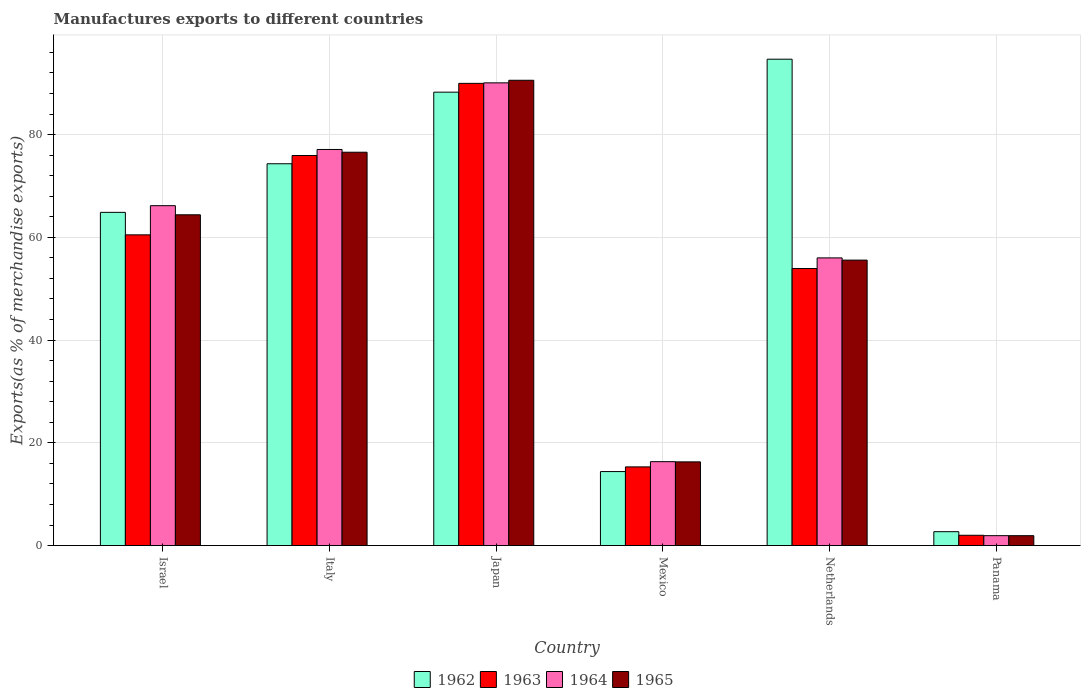How many different coloured bars are there?
Offer a terse response. 4. How many groups of bars are there?
Provide a short and direct response. 6. Are the number of bars per tick equal to the number of legend labels?
Ensure brevity in your answer.  Yes. How many bars are there on the 2nd tick from the left?
Your answer should be compact. 4. What is the label of the 6th group of bars from the left?
Provide a short and direct response. Panama. In how many cases, is the number of bars for a given country not equal to the number of legend labels?
Ensure brevity in your answer.  0. What is the percentage of exports to different countries in 1962 in Panama?
Provide a succinct answer. 2.7. Across all countries, what is the maximum percentage of exports to different countries in 1963?
Provide a short and direct response. 89.97. Across all countries, what is the minimum percentage of exports to different countries in 1965?
Offer a terse response. 1.92. In which country was the percentage of exports to different countries in 1964 minimum?
Give a very brief answer. Panama. What is the total percentage of exports to different countries in 1965 in the graph?
Give a very brief answer. 305.31. What is the difference between the percentage of exports to different countries in 1962 in Italy and that in Japan?
Provide a succinct answer. -13.94. What is the difference between the percentage of exports to different countries in 1965 in Japan and the percentage of exports to different countries in 1963 in Israel?
Give a very brief answer. 30.09. What is the average percentage of exports to different countries in 1965 per country?
Provide a succinct answer. 50.88. What is the difference between the percentage of exports to different countries of/in 1965 and percentage of exports to different countries of/in 1962 in Mexico?
Make the answer very short. 1.89. What is the ratio of the percentage of exports to different countries in 1962 in Japan to that in Mexico?
Provide a short and direct response. 6.13. Is the difference between the percentage of exports to different countries in 1965 in Israel and Netherlands greater than the difference between the percentage of exports to different countries in 1962 in Israel and Netherlands?
Give a very brief answer. Yes. What is the difference between the highest and the second highest percentage of exports to different countries in 1964?
Provide a succinct answer. -23.91. What is the difference between the highest and the lowest percentage of exports to different countries in 1964?
Keep it short and to the point. 88.15. What does the 2nd bar from the left in Italy represents?
Make the answer very short. 1963. What does the 2nd bar from the right in Italy represents?
Keep it short and to the point. 1964. Is it the case that in every country, the sum of the percentage of exports to different countries in 1965 and percentage of exports to different countries in 1963 is greater than the percentage of exports to different countries in 1964?
Your answer should be compact. Yes. Are all the bars in the graph horizontal?
Your answer should be very brief. No. How many countries are there in the graph?
Offer a terse response. 6. What is the difference between two consecutive major ticks on the Y-axis?
Provide a succinct answer. 20. Does the graph contain grids?
Give a very brief answer. Yes. How many legend labels are there?
Keep it short and to the point. 4. How are the legend labels stacked?
Your answer should be compact. Horizontal. What is the title of the graph?
Make the answer very short. Manufactures exports to different countries. Does "1970" appear as one of the legend labels in the graph?
Your answer should be very brief. No. What is the label or title of the X-axis?
Give a very brief answer. Country. What is the label or title of the Y-axis?
Make the answer very short. Exports(as % of merchandise exports). What is the Exports(as % of merchandise exports) of 1962 in Israel?
Offer a terse response. 64.86. What is the Exports(as % of merchandise exports) of 1963 in Israel?
Make the answer very short. 60.48. What is the Exports(as % of merchandise exports) of 1964 in Israel?
Ensure brevity in your answer.  66.16. What is the Exports(as % of merchandise exports) of 1965 in Israel?
Your response must be concise. 64.39. What is the Exports(as % of merchandise exports) of 1962 in Italy?
Provide a short and direct response. 74.32. What is the Exports(as % of merchandise exports) in 1963 in Italy?
Offer a terse response. 75.93. What is the Exports(as % of merchandise exports) of 1964 in Italy?
Keep it short and to the point. 77.1. What is the Exports(as % of merchandise exports) of 1965 in Italy?
Keep it short and to the point. 76.57. What is the Exports(as % of merchandise exports) in 1962 in Japan?
Offer a very short reply. 88.26. What is the Exports(as % of merchandise exports) of 1963 in Japan?
Your answer should be compact. 89.97. What is the Exports(as % of merchandise exports) of 1964 in Japan?
Keep it short and to the point. 90.07. What is the Exports(as % of merchandise exports) in 1965 in Japan?
Your response must be concise. 90.57. What is the Exports(as % of merchandise exports) in 1962 in Mexico?
Ensure brevity in your answer.  14.4. What is the Exports(as % of merchandise exports) of 1963 in Mexico?
Your answer should be very brief. 15.31. What is the Exports(as % of merchandise exports) of 1964 in Mexico?
Keep it short and to the point. 16.33. What is the Exports(as % of merchandise exports) in 1965 in Mexico?
Give a very brief answer. 16.29. What is the Exports(as % of merchandise exports) in 1962 in Netherlands?
Provide a succinct answer. 94.68. What is the Exports(as % of merchandise exports) in 1963 in Netherlands?
Offer a terse response. 53.93. What is the Exports(as % of merchandise exports) in 1964 in Netherlands?
Offer a very short reply. 56. What is the Exports(as % of merchandise exports) in 1965 in Netherlands?
Offer a very short reply. 55.57. What is the Exports(as % of merchandise exports) in 1962 in Panama?
Provide a succinct answer. 2.7. What is the Exports(as % of merchandise exports) of 1963 in Panama?
Give a very brief answer. 2. What is the Exports(as % of merchandise exports) in 1964 in Panama?
Offer a very short reply. 1.93. What is the Exports(as % of merchandise exports) of 1965 in Panama?
Ensure brevity in your answer.  1.92. Across all countries, what is the maximum Exports(as % of merchandise exports) in 1962?
Give a very brief answer. 94.68. Across all countries, what is the maximum Exports(as % of merchandise exports) of 1963?
Ensure brevity in your answer.  89.97. Across all countries, what is the maximum Exports(as % of merchandise exports) of 1964?
Provide a short and direct response. 90.07. Across all countries, what is the maximum Exports(as % of merchandise exports) of 1965?
Keep it short and to the point. 90.57. Across all countries, what is the minimum Exports(as % of merchandise exports) of 1962?
Provide a short and direct response. 2.7. Across all countries, what is the minimum Exports(as % of merchandise exports) of 1963?
Your answer should be compact. 2. Across all countries, what is the minimum Exports(as % of merchandise exports) in 1964?
Give a very brief answer. 1.93. Across all countries, what is the minimum Exports(as % of merchandise exports) in 1965?
Keep it short and to the point. 1.92. What is the total Exports(as % of merchandise exports) in 1962 in the graph?
Your response must be concise. 339.23. What is the total Exports(as % of merchandise exports) in 1963 in the graph?
Offer a very short reply. 297.63. What is the total Exports(as % of merchandise exports) in 1964 in the graph?
Offer a terse response. 307.59. What is the total Exports(as % of merchandise exports) in 1965 in the graph?
Provide a short and direct response. 305.31. What is the difference between the Exports(as % of merchandise exports) in 1962 in Israel and that in Italy?
Your response must be concise. -9.46. What is the difference between the Exports(as % of merchandise exports) in 1963 in Israel and that in Italy?
Keep it short and to the point. -15.45. What is the difference between the Exports(as % of merchandise exports) in 1964 in Israel and that in Italy?
Keep it short and to the point. -10.94. What is the difference between the Exports(as % of merchandise exports) in 1965 in Israel and that in Italy?
Your answer should be very brief. -12.18. What is the difference between the Exports(as % of merchandise exports) in 1962 in Israel and that in Japan?
Keep it short and to the point. -23.4. What is the difference between the Exports(as % of merchandise exports) in 1963 in Israel and that in Japan?
Your answer should be compact. -29.49. What is the difference between the Exports(as % of merchandise exports) in 1964 in Israel and that in Japan?
Ensure brevity in your answer.  -23.91. What is the difference between the Exports(as % of merchandise exports) of 1965 in Israel and that in Japan?
Offer a terse response. -26.18. What is the difference between the Exports(as % of merchandise exports) in 1962 in Israel and that in Mexico?
Your answer should be very brief. 50.46. What is the difference between the Exports(as % of merchandise exports) in 1963 in Israel and that in Mexico?
Give a very brief answer. 45.17. What is the difference between the Exports(as % of merchandise exports) of 1964 in Israel and that in Mexico?
Make the answer very short. 49.83. What is the difference between the Exports(as % of merchandise exports) in 1965 in Israel and that in Mexico?
Offer a very short reply. 48.1. What is the difference between the Exports(as % of merchandise exports) in 1962 in Israel and that in Netherlands?
Your answer should be very brief. -29.81. What is the difference between the Exports(as % of merchandise exports) of 1963 in Israel and that in Netherlands?
Give a very brief answer. 6.55. What is the difference between the Exports(as % of merchandise exports) of 1964 in Israel and that in Netherlands?
Your answer should be compact. 10.16. What is the difference between the Exports(as % of merchandise exports) in 1965 in Israel and that in Netherlands?
Keep it short and to the point. 8.82. What is the difference between the Exports(as % of merchandise exports) of 1962 in Israel and that in Panama?
Offer a very short reply. 62.16. What is the difference between the Exports(as % of merchandise exports) in 1963 in Israel and that in Panama?
Your answer should be very brief. 58.48. What is the difference between the Exports(as % of merchandise exports) of 1964 in Israel and that in Panama?
Make the answer very short. 64.23. What is the difference between the Exports(as % of merchandise exports) in 1965 in Israel and that in Panama?
Offer a very short reply. 62.47. What is the difference between the Exports(as % of merchandise exports) of 1962 in Italy and that in Japan?
Ensure brevity in your answer.  -13.94. What is the difference between the Exports(as % of merchandise exports) in 1963 in Italy and that in Japan?
Keep it short and to the point. -14.04. What is the difference between the Exports(as % of merchandise exports) in 1964 in Italy and that in Japan?
Provide a short and direct response. -12.97. What is the difference between the Exports(as % of merchandise exports) in 1965 in Italy and that in Japan?
Make the answer very short. -14.01. What is the difference between the Exports(as % of merchandise exports) in 1962 in Italy and that in Mexico?
Make the answer very short. 59.92. What is the difference between the Exports(as % of merchandise exports) in 1963 in Italy and that in Mexico?
Provide a short and direct response. 60.61. What is the difference between the Exports(as % of merchandise exports) of 1964 in Italy and that in Mexico?
Make the answer very short. 60.77. What is the difference between the Exports(as % of merchandise exports) in 1965 in Italy and that in Mexico?
Provide a succinct answer. 60.28. What is the difference between the Exports(as % of merchandise exports) of 1962 in Italy and that in Netherlands?
Give a very brief answer. -20.36. What is the difference between the Exports(as % of merchandise exports) in 1963 in Italy and that in Netherlands?
Give a very brief answer. 22. What is the difference between the Exports(as % of merchandise exports) in 1964 in Italy and that in Netherlands?
Provide a short and direct response. 21.11. What is the difference between the Exports(as % of merchandise exports) of 1965 in Italy and that in Netherlands?
Ensure brevity in your answer.  21. What is the difference between the Exports(as % of merchandise exports) of 1962 in Italy and that in Panama?
Your answer should be very brief. 71.62. What is the difference between the Exports(as % of merchandise exports) in 1963 in Italy and that in Panama?
Give a very brief answer. 73.92. What is the difference between the Exports(as % of merchandise exports) in 1964 in Italy and that in Panama?
Give a very brief answer. 75.18. What is the difference between the Exports(as % of merchandise exports) of 1965 in Italy and that in Panama?
Your response must be concise. 74.64. What is the difference between the Exports(as % of merchandise exports) of 1962 in Japan and that in Mexico?
Offer a terse response. 73.86. What is the difference between the Exports(as % of merchandise exports) of 1963 in Japan and that in Mexico?
Provide a succinct answer. 74.66. What is the difference between the Exports(as % of merchandise exports) in 1964 in Japan and that in Mexico?
Offer a terse response. 73.74. What is the difference between the Exports(as % of merchandise exports) of 1965 in Japan and that in Mexico?
Your answer should be compact. 74.28. What is the difference between the Exports(as % of merchandise exports) in 1962 in Japan and that in Netherlands?
Offer a very short reply. -6.42. What is the difference between the Exports(as % of merchandise exports) in 1963 in Japan and that in Netherlands?
Offer a very short reply. 36.04. What is the difference between the Exports(as % of merchandise exports) in 1964 in Japan and that in Netherlands?
Keep it short and to the point. 34.07. What is the difference between the Exports(as % of merchandise exports) of 1965 in Japan and that in Netherlands?
Offer a terse response. 35.01. What is the difference between the Exports(as % of merchandise exports) in 1962 in Japan and that in Panama?
Your response must be concise. 85.56. What is the difference between the Exports(as % of merchandise exports) in 1963 in Japan and that in Panama?
Make the answer very short. 87.97. What is the difference between the Exports(as % of merchandise exports) in 1964 in Japan and that in Panama?
Your response must be concise. 88.15. What is the difference between the Exports(as % of merchandise exports) of 1965 in Japan and that in Panama?
Provide a short and direct response. 88.65. What is the difference between the Exports(as % of merchandise exports) of 1962 in Mexico and that in Netherlands?
Make the answer very short. -80.27. What is the difference between the Exports(as % of merchandise exports) in 1963 in Mexico and that in Netherlands?
Provide a short and direct response. -38.62. What is the difference between the Exports(as % of merchandise exports) of 1964 in Mexico and that in Netherlands?
Your answer should be compact. -39.67. What is the difference between the Exports(as % of merchandise exports) in 1965 in Mexico and that in Netherlands?
Ensure brevity in your answer.  -39.28. What is the difference between the Exports(as % of merchandise exports) of 1962 in Mexico and that in Panama?
Ensure brevity in your answer.  11.7. What is the difference between the Exports(as % of merchandise exports) in 1963 in Mexico and that in Panama?
Provide a succinct answer. 13.31. What is the difference between the Exports(as % of merchandise exports) in 1964 in Mexico and that in Panama?
Provide a succinct answer. 14.4. What is the difference between the Exports(as % of merchandise exports) of 1965 in Mexico and that in Panama?
Your response must be concise. 14.37. What is the difference between the Exports(as % of merchandise exports) in 1962 in Netherlands and that in Panama?
Your response must be concise. 91.97. What is the difference between the Exports(as % of merchandise exports) of 1963 in Netherlands and that in Panama?
Provide a succinct answer. 51.93. What is the difference between the Exports(as % of merchandise exports) of 1964 in Netherlands and that in Panama?
Your response must be concise. 54.07. What is the difference between the Exports(as % of merchandise exports) of 1965 in Netherlands and that in Panama?
Provide a succinct answer. 53.64. What is the difference between the Exports(as % of merchandise exports) of 1962 in Israel and the Exports(as % of merchandise exports) of 1963 in Italy?
Give a very brief answer. -11.07. What is the difference between the Exports(as % of merchandise exports) of 1962 in Israel and the Exports(as % of merchandise exports) of 1964 in Italy?
Give a very brief answer. -12.24. What is the difference between the Exports(as % of merchandise exports) in 1962 in Israel and the Exports(as % of merchandise exports) in 1965 in Italy?
Provide a succinct answer. -11.7. What is the difference between the Exports(as % of merchandise exports) of 1963 in Israel and the Exports(as % of merchandise exports) of 1964 in Italy?
Your answer should be very brief. -16.62. What is the difference between the Exports(as % of merchandise exports) in 1963 in Israel and the Exports(as % of merchandise exports) in 1965 in Italy?
Offer a very short reply. -16.08. What is the difference between the Exports(as % of merchandise exports) of 1964 in Israel and the Exports(as % of merchandise exports) of 1965 in Italy?
Offer a very short reply. -10.41. What is the difference between the Exports(as % of merchandise exports) in 1962 in Israel and the Exports(as % of merchandise exports) in 1963 in Japan?
Your answer should be very brief. -25.11. What is the difference between the Exports(as % of merchandise exports) of 1962 in Israel and the Exports(as % of merchandise exports) of 1964 in Japan?
Give a very brief answer. -25.21. What is the difference between the Exports(as % of merchandise exports) of 1962 in Israel and the Exports(as % of merchandise exports) of 1965 in Japan?
Ensure brevity in your answer.  -25.71. What is the difference between the Exports(as % of merchandise exports) in 1963 in Israel and the Exports(as % of merchandise exports) in 1964 in Japan?
Provide a succinct answer. -29.59. What is the difference between the Exports(as % of merchandise exports) in 1963 in Israel and the Exports(as % of merchandise exports) in 1965 in Japan?
Make the answer very short. -30.09. What is the difference between the Exports(as % of merchandise exports) of 1964 in Israel and the Exports(as % of merchandise exports) of 1965 in Japan?
Ensure brevity in your answer.  -24.41. What is the difference between the Exports(as % of merchandise exports) of 1962 in Israel and the Exports(as % of merchandise exports) of 1963 in Mexico?
Ensure brevity in your answer.  49.55. What is the difference between the Exports(as % of merchandise exports) in 1962 in Israel and the Exports(as % of merchandise exports) in 1964 in Mexico?
Your response must be concise. 48.53. What is the difference between the Exports(as % of merchandise exports) of 1962 in Israel and the Exports(as % of merchandise exports) of 1965 in Mexico?
Your answer should be compact. 48.57. What is the difference between the Exports(as % of merchandise exports) of 1963 in Israel and the Exports(as % of merchandise exports) of 1964 in Mexico?
Provide a succinct answer. 44.15. What is the difference between the Exports(as % of merchandise exports) in 1963 in Israel and the Exports(as % of merchandise exports) in 1965 in Mexico?
Provide a short and direct response. 44.19. What is the difference between the Exports(as % of merchandise exports) in 1964 in Israel and the Exports(as % of merchandise exports) in 1965 in Mexico?
Provide a short and direct response. 49.87. What is the difference between the Exports(as % of merchandise exports) in 1962 in Israel and the Exports(as % of merchandise exports) in 1963 in Netherlands?
Your answer should be compact. 10.93. What is the difference between the Exports(as % of merchandise exports) in 1962 in Israel and the Exports(as % of merchandise exports) in 1964 in Netherlands?
Ensure brevity in your answer.  8.87. What is the difference between the Exports(as % of merchandise exports) of 1962 in Israel and the Exports(as % of merchandise exports) of 1965 in Netherlands?
Ensure brevity in your answer.  9.3. What is the difference between the Exports(as % of merchandise exports) of 1963 in Israel and the Exports(as % of merchandise exports) of 1964 in Netherlands?
Give a very brief answer. 4.49. What is the difference between the Exports(as % of merchandise exports) of 1963 in Israel and the Exports(as % of merchandise exports) of 1965 in Netherlands?
Keep it short and to the point. 4.92. What is the difference between the Exports(as % of merchandise exports) of 1964 in Israel and the Exports(as % of merchandise exports) of 1965 in Netherlands?
Make the answer very short. 10.59. What is the difference between the Exports(as % of merchandise exports) in 1962 in Israel and the Exports(as % of merchandise exports) in 1963 in Panama?
Your response must be concise. 62.86. What is the difference between the Exports(as % of merchandise exports) in 1962 in Israel and the Exports(as % of merchandise exports) in 1964 in Panama?
Keep it short and to the point. 62.94. What is the difference between the Exports(as % of merchandise exports) in 1962 in Israel and the Exports(as % of merchandise exports) in 1965 in Panama?
Your response must be concise. 62.94. What is the difference between the Exports(as % of merchandise exports) of 1963 in Israel and the Exports(as % of merchandise exports) of 1964 in Panama?
Ensure brevity in your answer.  58.56. What is the difference between the Exports(as % of merchandise exports) in 1963 in Israel and the Exports(as % of merchandise exports) in 1965 in Panama?
Provide a succinct answer. 58.56. What is the difference between the Exports(as % of merchandise exports) in 1964 in Israel and the Exports(as % of merchandise exports) in 1965 in Panama?
Offer a terse response. 64.24. What is the difference between the Exports(as % of merchandise exports) in 1962 in Italy and the Exports(as % of merchandise exports) in 1963 in Japan?
Make the answer very short. -15.65. What is the difference between the Exports(as % of merchandise exports) of 1962 in Italy and the Exports(as % of merchandise exports) of 1964 in Japan?
Offer a terse response. -15.75. What is the difference between the Exports(as % of merchandise exports) of 1962 in Italy and the Exports(as % of merchandise exports) of 1965 in Japan?
Your response must be concise. -16.25. What is the difference between the Exports(as % of merchandise exports) in 1963 in Italy and the Exports(as % of merchandise exports) in 1964 in Japan?
Offer a terse response. -14.14. What is the difference between the Exports(as % of merchandise exports) of 1963 in Italy and the Exports(as % of merchandise exports) of 1965 in Japan?
Give a very brief answer. -14.64. What is the difference between the Exports(as % of merchandise exports) in 1964 in Italy and the Exports(as % of merchandise exports) in 1965 in Japan?
Provide a short and direct response. -13.47. What is the difference between the Exports(as % of merchandise exports) of 1962 in Italy and the Exports(as % of merchandise exports) of 1963 in Mexico?
Provide a succinct answer. 59.01. What is the difference between the Exports(as % of merchandise exports) in 1962 in Italy and the Exports(as % of merchandise exports) in 1964 in Mexico?
Give a very brief answer. 57.99. What is the difference between the Exports(as % of merchandise exports) of 1962 in Italy and the Exports(as % of merchandise exports) of 1965 in Mexico?
Your answer should be compact. 58.03. What is the difference between the Exports(as % of merchandise exports) of 1963 in Italy and the Exports(as % of merchandise exports) of 1964 in Mexico?
Provide a succinct answer. 59.6. What is the difference between the Exports(as % of merchandise exports) of 1963 in Italy and the Exports(as % of merchandise exports) of 1965 in Mexico?
Ensure brevity in your answer.  59.64. What is the difference between the Exports(as % of merchandise exports) of 1964 in Italy and the Exports(as % of merchandise exports) of 1965 in Mexico?
Provide a short and direct response. 60.81. What is the difference between the Exports(as % of merchandise exports) of 1962 in Italy and the Exports(as % of merchandise exports) of 1963 in Netherlands?
Offer a terse response. 20.39. What is the difference between the Exports(as % of merchandise exports) of 1962 in Italy and the Exports(as % of merchandise exports) of 1964 in Netherlands?
Make the answer very short. 18.32. What is the difference between the Exports(as % of merchandise exports) in 1962 in Italy and the Exports(as % of merchandise exports) in 1965 in Netherlands?
Your response must be concise. 18.76. What is the difference between the Exports(as % of merchandise exports) in 1963 in Italy and the Exports(as % of merchandise exports) in 1964 in Netherlands?
Provide a short and direct response. 19.93. What is the difference between the Exports(as % of merchandise exports) of 1963 in Italy and the Exports(as % of merchandise exports) of 1965 in Netherlands?
Keep it short and to the point. 20.36. What is the difference between the Exports(as % of merchandise exports) in 1964 in Italy and the Exports(as % of merchandise exports) in 1965 in Netherlands?
Offer a very short reply. 21.54. What is the difference between the Exports(as % of merchandise exports) in 1962 in Italy and the Exports(as % of merchandise exports) in 1963 in Panama?
Offer a very short reply. 72.32. What is the difference between the Exports(as % of merchandise exports) of 1962 in Italy and the Exports(as % of merchandise exports) of 1964 in Panama?
Keep it short and to the point. 72.39. What is the difference between the Exports(as % of merchandise exports) of 1962 in Italy and the Exports(as % of merchandise exports) of 1965 in Panama?
Offer a very short reply. 72.4. What is the difference between the Exports(as % of merchandise exports) of 1963 in Italy and the Exports(as % of merchandise exports) of 1964 in Panama?
Offer a terse response. 74. What is the difference between the Exports(as % of merchandise exports) in 1963 in Italy and the Exports(as % of merchandise exports) in 1965 in Panama?
Provide a succinct answer. 74.01. What is the difference between the Exports(as % of merchandise exports) of 1964 in Italy and the Exports(as % of merchandise exports) of 1965 in Panama?
Your answer should be compact. 75.18. What is the difference between the Exports(as % of merchandise exports) of 1962 in Japan and the Exports(as % of merchandise exports) of 1963 in Mexico?
Keep it short and to the point. 72.95. What is the difference between the Exports(as % of merchandise exports) in 1962 in Japan and the Exports(as % of merchandise exports) in 1964 in Mexico?
Give a very brief answer. 71.93. What is the difference between the Exports(as % of merchandise exports) in 1962 in Japan and the Exports(as % of merchandise exports) in 1965 in Mexico?
Keep it short and to the point. 71.97. What is the difference between the Exports(as % of merchandise exports) of 1963 in Japan and the Exports(as % of merchandise exports) of 1964 in Mexico?
Your answer should be very brief. 73.64. What is the difference between the Exports(as % of merchandise exports) in 1963 in Japan and the Exports(as % of merchandise exports) in 1965 in Mexico?
Your answer should be very brief. 73.68. What is the difference between the Exports(as % of merchandise exports) in 1964 in Japan and the Exports(as % of merchandise exports) in 1965 in Mexico?
Offer a terse response. 73.78. What is the difference between the Exports(as % of merchandise exports) in 1962 in Japan and the Exports(as % of merchandise exports) in 1963 in Netherlands?
Offer a very short reply. 34.33. What is the difference between the Exports(as % of merchandise exports) in 1962 in Japan and the Exports(as % of merchandise exports) in 1964 in Netherlands?
Keep it short and to the point. 32.26. What is the difference between the Exports(as % of merchandise exports) of 1962 in Japan and the Exports(as % of merchandise exports) of 1965 in Netherlands?
Your answer should be very brief. 32.69. What is the difference between the Exports(as % of merchandise exports) in 1963 in Japan and the Exports(as % of merchandise exports) in 1964 in Netherlands?
Your response must be concise. 33.97. What is the difference between the Exports(as % of merchandise exports) of 1963 in Japan and the Exports(as % of merchandise exports) of 1965 in Netherlands?
Offer a very short reply. 34.41. What is the difference between the Exports(as % of merchandise exports) of 1964 in Japan and the Exports(as % of merchandise exports) of 1965 in Netherlands?
Ensure brevity in your answer.  34.51. What is the difference between the Exports(as % of merchandise exports) of 1962 in Japan and the Exports(as % of merchandise exports) of 1963 in Panama?
Provide a succinct answer. 86.26. What is the difference between the Exports(as % of merchandise exports) in 1962 in Japan and the Exports(as % of merchandise exports) in 1964 in Panama?
Offer a very short reply. 86.33. What is the difference between the Exports(as % of merchandise exports) in 1962 in Japan and the Exports(as % of merchandise exports) in 1965 in Panama?
Ensure brevity in your answer.  86.34. What is the difference between the Exports(as % of merchandise exports) in 1963 in Japan and the Exports(as % of merchandise exports) in 1964 in Panama?
Provide a succinct answer. 88.05. What is the difference between the Exports(as % of merchandise exports) in 1963 in Japan and the Exports(as % of merchandise exports) in 1965 in Panama?
Your response must be concise. 88.05. What is the difference between the Exports(as % of merchandise exports) of 1964 in Japan and the Exports(as % of merchandise exports) of 1965 in Panama?
Keep it short and to the point. 88.15. What is the difference between the Exports(as % of merchandise exports) in 1962 in Mexico and the Exports(as % of merchandise exports) in 1963 in Netherlands?
Offer a terse response. -39.53. What is the difference between the Exports(as % of merchandise exports) of 1962 in Mexico and the Exports(as % of merchandise exports) of 1964 in Netherlands?
Provide a succinct answer. -41.59. What is the difference between the Exports(as % of merchandise exports) of 1962 in Mexico and the Exports(as % of merchandise exports) of 1965 in Netherlands?
Your answer should be compact. -41.16. What is the difference between the Exports(as % of merchandise exports) in 1963 in Mexico and the Exports(as % of merchandise exports) in 1964 in Netherlands?
Your response must be concise. -40.68. What is the difference between the Exports(as % of merchandise exports) of 1963 in Mexico and the Exports(as % of merchandise exports) of 1965 in Netherlands?
Offer a terse response. -40.25. What is the difference between the Exports(as % of merchandise exports) of 1964 in Mexico and the Exports(as % of merchandise exports) of 1965 in Netherlands?
Your response must be concise. -39.24. What is the difference between the Exports(as % of merchandise exports) of 1962 in Mexico and the Exports(as % of merchandise exports) of 1963 in Panama?
Ensure brevity in your answer.  12.4. What is the difference between the Exports(as % of merchandise exports) in 1962 in Mexico and the Exports(as % of merchandise exports) in 1964 in Panama?
Your response must be concise. 12.48. What is the difference between the Exports(as % of merchandise exports) of 1962 in Mexico and the Exports(as % of merchandise exports) of 1965 in Panama?
Make the answer very short. 12.48. What is the difference between the Exports(as % of merchandise exports) of 1963 in Mexico and the Exports(as % of merchandise exports) of 1964 in Panama?
Your answer should be very brief. 13.39. What is the difference between the Exports(as % of merchandise exports) of 1963 in Mexico and the Exports(as % of merchandise exports) of 1965 in Panama?
Make the answer very short. 13.39. What is the difference between the Exports(as % of merchandise exports) of 1964 in Mexico and the Exports(as % of merchandise exports) of 1965 in Panama?
Your response must be concise. 14.41. What is the difference between the Exports(as % of merchandise exports) of 1962 in Netherlands and the Exports(as % of merchandise exports) of 1963 in Panama?
Provide a succinct answer. 92.67. What is the difference between the Exports(as % of merchandise exports) of 1962 in Netherlands and the Exports(as % of merchandise exports) of 1964 in Panama?
Provide a short and direct response. 92.75. What is the difference between the Exports(as % of merchandise exports) in 1962 in Netherlands and the Exports(as % of merchandise exports) in 1965 in Panama?
Offer a terse response. 92.75. What is the difference between the Exports(as % of merchandise exports) of 1963 in Netherlands and the Exports(as % of merchandise exports) of 1964 in Panama?
Make the answer very short. 52. What is the difference between the Exports(as % of merchandise exports) of 1963 in Netherlands and the Exports(as % of merchandise exports) of 1965 in Panama?
Your answer should be very brief. 52.01. What is the difference between the Exports(as % of merchandise exports) of 1964 in Netherlands and the Exports(as % of merchandise exports) of 1965 in Panama?
Your answer should be very brief. 54.07. What is the average Exports(as % of merchandise exports) of 1962 per country?
Provide a short and direct response. 56.54. What is the average Exports(as % of merchandise exports) of 1963 per country?
Your answer should be compact. 49.61. What is the average Exports(as % of merchandise exports) of 1964 per country?
Your answer should be compact. 51.27. What is the average Exports(as % of merchandise exports) of 1965 per country?
Provide a short and direct response. 50.88. What is the difference between the Exports(as % of merchandise exports) of 1962 and Exports(as % of merchandise exports) of 1963 in Israel?
Provide a short and direct response. 4.38. What is the difference between the Exports(as % of merchandise exports) of 1962 and Exports(as % of merchandise exports) of 1964 in Israel?
Your response must be concise. -1.3. What is the difference between the Exports(as % of merchandise exports) of 1962 and Exports(as % of merchandise exports) of 1965 in Israel?
Provide a succinct answer. 0.47. What is the difference between the Exports(as % of merchandise exports) in 1963 and Exports(as % of merchandise exports) in 1964 in Israel?
Your answer should be compact. -5.68. What is the difference between the Exports(as % of merchandise exports) of 1963 and Exports(as % of merchandise exports) of 1965 in Israel?
Your answer should be very brief. -3.91. What is the difference between the Exports(as % of merchandise exports) in 1964 and Exports(as % of merchandise exports) in 1965 in Israel?
Provide a short and direct response. 1.77. What is the difference between the Exports(as % of merchandise exports) in 1962 and Exports(as % of merchandise exports) in 1963 in Italy?
Your answer should be compact. -1.61. What is the difference between the Exports(as % of merchandise exports) in 1962 and Exports(as % of merchandise exports) in 1964 in Italy?
Your answer should be very brief. -2.78. What is the difference between the Exports(as % of merchandise exports) in 1962 and Exports(as % of merchandise exports) in 1965 in Italy?
Provide a short and direct response. -2.25. What is the difference between the Exports(as % of merchandise exports) in 1963 and Exports(as % of merchandise exports) in 1964 in Italy?
Offer a very short reply. -1.17. What is the difference between the Exports(as % of merchandise exports) in 1963 and Exports(as % of merchandise exports) in 1965 in Italy?
Your answer should be compact. -0.64. What is the difference between the Exports(as % of merchandise exports) in 1964 and Exports(as % of merchandise exports) in 1965 in Italy?
Your answer should be compact. 0.54. What is the difference between the Exports(as % of merchandise exports) of 1962 and Exports(as % of merchandise exports) of 1963 in Japan?
Your answer should be very brief. -1.71. What is the difference between the Exports(as % of merchandise exports) of 1962 and Exports(as % of merchandise exports) of 1964 in Japan?
Ensure brevity in your answer.  -1.81. What is the difference between the Exports(as % of merchandise exports) of 1962 and Exports(as % of merchandise exports) of 1965 in Japan?
Your answer should be very brief. -2.31. What is the difference between the Exports(as % of merchandise exports) of 1963 and Exports(as % of merchandise exports) of 1964 in Japan?
Your answer should be very brief. -0.1. What is the difference between the Exports(as % of merchandise exports) of 1963 and Exports(as % of merchandise exports) of 1965 in Japan?
Provide a short and direct response. -0.6. What is the difference between the Exports(as % of merchandise exports) in 1964 and Exports(as % of merchandise exports) in 1965 in Japan?
Your answer should be very brief. -0.5. What is the difference between the Exports(as % of merchandise exports) of 1962 and Exports(as % of merchandise exports) of 1963 in Mexico?
Give a very brief answer. -0.91. What is the difference between the Exports(as % of merchandise exports) of 1962 and Exports(as % of merchandise exports) of 1964 in Mexico?
Provide a short and direct response. -1.93. What is the difference between the Exports(as % of merchandise exports) in 1962 and Exports(as % of merchandise exports) in 1965 in Mexico?
Give a very brief answer. -1.89. What is the difference between the Exports(as % of merchandise exports) of 1963 and Exports(as % of merchandise exports) of 1964 in Mexico?
Your answer should be very brief. -1.02. What is the difference between the Exports(as % of merchandise exports) of 1963 and Exports(as % of merchandise exports) of 1965 in Mexico?
Provide a short and direct response. -0.98. What is the difference between the Exports(as % of merchandise exports) of 1964 and Exports(as % of merchandise exports) of 1965 in Mexico?
Your answer should be very brief. 0.04. What is the difference between the Exports(as % of merchandise exports) in 1962 and Exports(as % of merchandise exports) in 1963 in Netherlands?
Provide a succinct answer. 40.75. What is the difference between the Exports(as % of merchandise exports) in 1962 and Exports(as % of merchandise exports) in 1964 in Netherlands?
Your response must be concise. 38.68. What is the difference between the Exports(as % of merchandise exports) in 1962 and Exports(as % of merchandise exports) in 1965 in Netherlands?
Keep it short and to the point. 39.11. What is the difference between the Exports(as % of merchandise exports) in 1963 and Exports(as % of merchandise exports) in 1964 in Netherlands?
Give a very brief answer. -2.07. What is the difference between the Exports(as % of merchandise exports) of 1963 and Exports(as % of merchandise exports) of 1965 in Netherlands?
Make the answer very short. -1.64. What is the difference between the Exports(as % of merchandise exports) in 1964 and Exports(as % of merchandise exports) in 1965 in Netherlands?
Ensure brevity in your answer.  0.43. What is the difference between the Exports(as % of merchandise exports) of 1962 and Exports(as % of merchandise exports) of 1963 in Panama?
Offer a very short reply. 0.7. What is the difference between the Exports(as % of merchandise exports) of 1962 and Exports(as % of merchandise exports) of 1964 in Panama?
Provide a short and direct response. 0.78. What is the difference between the Exports(as % of merchandise exports) of 1962 and Exports(as % of merchandise exports) of 1965 in Panama?
Provide a succinct answer. 0.78. What is the difference between the Exports(as % of merchandise exports) of 1963 and Exports(as % of merchandise exports) of 1964 in Panama?
Your answer should be compact. 0.08. What is the difference between the Exports(as % of merchandise exports) in 1963 and Exports(as % of merchandise exports) in 1965 in Panama?
Make the answer very short. 0.08. What is the difference between the Exports(as % of merchandise exports) in 1964 and Exports(as % of merchandise exports) in 1965 in Panama?
Your response must be concise. 0. What is the ratio of the Exports(as % of merchandise exports) of 1962 in Israel to that in Italy?
Keep it short and to the point. 0.87. What is the ratio of the Exports(as % of merchandise exports) in 1963 in Israel to that in Italy?
Keep it short and to the point. 0.8. What is the ratio of the Exports(as % of merchandise exports) in 1964 in Israel to that in Italy?
Give a very brief answer. 0.86. What is the ratio of the Exports(as % of merchandise exports) of 1965 in Israel to that in Italy?
Ensure brevity in your answer.  0.84. What is the ratio of the Exports(as % of merchandise exports) in 1962 in Israel to that in Japan?
Provide a succinct answer. 0.73. What is the ratio of the Exports(as % of merchandise exports) of 1963 in Israel to that in Japan?
Offer a terse response. 0.67. What is the ratio of the Exports(as % of merchandise exports) in 1964 in Israel to that in Japan?
Offer a terse response. 0.73. What is the ratio of the Exports(as % of merchandise exports) in 1965 in Israel to that in Japan?
Your answer should be compact. 0.71. What is the ratio of the Exports(as % of merchandise exports) of 1962 in Israel to that in Mexico?
Your answer should be very brief. 4.5. What is the ratio of the Exports(as % of merchandise exports) in 1963 in Israel to that in Mexico?
Ensure brevity in your answer.  3.95. What is the ratio of the Exports(as % of merchandise exports) of 1964 in Israel to that in Mexico?
Ensure brevity in your answer.  4.05. What is the ratio of the Exports(as % of merchandise exports) in 1965 in Israel to that in Mexico?
Offer a very short reply. 3.95. What is the ratio of the Exports(as % of merchandise exports) of 1962 in Israel to that in Netherlands?
Give a very brief answer. 0.69. What is the ratio of the Exports(as % of merchandise exports) of 1963 in Israel to that in Netherlands?
Provide a short and direct response. 1.12. What is the ratio of the Exports(as % of merchandise exports) in 1964 in Israel to that in Netherlands?
Offer a very short reply. 1.18. What is the ratio of the Exports(as % of merchandise exports) of 1965 in Israel to that in Netherlands?
Keep it short and to the point. 1.16. What is the ratio of the Exports(as % of merchandise exports) in 1962 in Israel to that in Panama?
Provide a short and direct response. 23.99. What is the ratio of the Exports(as % of merchandise exports) in 1963 in Israel to that in Panama?
Your answer should be very brief. 30.18. What is the ratio of the Exports(as % of merchandise exports) in 1964 in Israel to that in Panama?
Your answer should be very brief. 34.34. What is the ratio of the Exports(as % of merchandise exports) in 1965 in Israel to that in Panama?
Your response must be concise. 33.49. What is the ratio of the Exports(as % of merchandise exports) of 1962 in Italy to that in Japan?
Offer a very short reply. 0.84. What is the ratio of the Exports(as % of merchandise exports) of 1963 in Italy to that in Japan?
Ensure brevity in your answer.  0.84. What is the ratio of the Exports(as % of merchandise exports) in 1964 in Italy to that in Japan?
Ensure brevity in your answer.  0.86. What is the ratio of the Exports(as % of merchandise exports) in 1965 in Italy to that in Japan?
Your answer should be compact. 0.85. What is the ratio of the Exports(as % of merchandise exports) in 1962 in Italy to that in Mexico?
Ensure brevity in your answer.  5.16. What is the ratio of the Exports(as % of merchandise exports) in 1963 in Italy to that in Mexico?
Make the answer very short. 4.96. What is the ratio of the Exports(as % of merchandise exports) of 1964 in Italy to that in Mexico?
Offer a very short reply. 4.72. What is the ratio of the Exports(as % of merchandise exports) in 1965 in Italy to that in Mexico?
Keep it short and to the point. 4.7. What is the ratio of the Exports(as % of merchandise exports) of 1962 in Italy to that in Netherlands?
Your answer should be very brief. 0.79. What is the ratio of the Exports(as % of merchandise exports) in 1963 in Italy to that in Netherlands?
Provide a succinct answer. 1.41. What is the ratio of the Exports(as % of merchandise exports) of 1964 in Italy to that in Netherlands?
Your response must be concise. 1.38. What is the ratio of the Exports(as % of merchandise exports) in 1965 in Italy to that in Netherlands?
Offer a terse response. 1.38. What is the ratio of the Exports(as % of merchandise exports) of 1962 in Italy to that in Panama?
Ensure brevity in your answer.  27.49. What is the ratio of the Exports(as % of merchandise exports) of 1963 in Italy to that in Panama?
Your response must be concise. 37.88. What is the ratio of the Exports(as % of merchandise exports) of 1964 in Italy to that in Panama?
Provide a short and direct response. 40.02. What is the ratio of the Exports(as % of merchandise exports) in 1965 in Italy to that in Panama?
Offer a terse response. 39.82. What is the ratio of the Exports(as % of merchandise exports) of 1962 in Japan to that in Mexico?
Ensure brevity in your answer.  6.13. What is the ratio of the Exports(as % of merchandise exports) of 1963 in Japan to that in Mexico?
Your response must be concise. 5.88. What is the ratio of the Exports(as % of merchandise exports) of 1964 in Japan to that in Mexico?
Ensure brevity in your answer.  5.52. What is the ratio of the Exports(as % of merchandise exports) of 1965 in Japan to that in Mexico?
Give a very brief answer. 5.56. What is the ratio of the Exports(as % of merchandise exports) in 1962 in Japan to that in Netherlands?
Your answer should be compact. 0.93. What is the ratio of the Exports(as % of merchandise exports) of 1963 in Japan to that in Netherlands?
Ensure brevity in your answer.  1.67. What is the ratio of the Exports(as % of merchandise exports) of 1964 in Japan to that in Netherlands?
Offer a very short reply. 1.61. What is the ratio of the Exports(as % of merchandise exports) in 1965 in Japan to that in Netherlands?
Your response must be concise. 1.63. What is the ratio of the Exports(as % of merchandise exports) in 1962 in Japan to that in Panama?
Provide a succinct answer. 32.64. What is the ratio of the Exports(as % of merchandise exports) in 1963 in Japan to that in Panama?
Ensure brevity in your answer.  44.89. What is the ratio of the Exports(as % of merchandise exports) in 1964 in Japan to that in Panama?
Your response must be concise. 46.75. What is the ratio of the Exports(as % of merchandise exports) of 1965 in Japan to that in Panama?
Give a very brief answer. 47.1. What is the ratio of the Exports(as % of merchandise exports) in 1962 in Mexico to that in Netherlands?
Offer a very short reply. 0.15. What is the ratio of the Exports(as % of merchandise exports) of 1963 in Mexico to that in Netherlands?
Offer a terse response. 0.28. What is the ratio of the Exports(as % of merchandise exports) in 1964 in Mexico to that in Netherlands?
Offer a terse response. 0.29. What is the ratio of the Exports(as % of merchandise exports) of 1965 in Mexico to that in Netherlands?
Make the answer very short. 0.29. What is the ratio of the Exports(as % of merchandise exports) of 1962 in Mexico to that in Panama?
Provide a short and direct response. 5.33. What is the ratio of the Exports(as % of merchandise exports) of 1963 in Mexico to that in Panama?
Provide a succinct answer. 7.64. What is the ratio of the Exports(as % of merchandise exports) in 1964 in Mexico to that in Panama?
Your answer should be very brief. 8.48. What is the ratio of the Exports(as % of merchandise exports) in 1965 in Mexico to that in Panama?
Your answer should be very brief. 8.47. What is the ratio of the Exports(as % of merchandise exports) in 1962 in Netherlands to that in Panama?
Your response must be concise. 35.02. What is the ratio of the Exports(as % of merchandise exports) in 1963 in Netherlands to that in Panama?
Offer a very short reply. 26.91. What is the ratio of the Exports(as % of merchandise exports) in 1964 in Netherlands to that in Panama?
Keep it short and to the point. 29.06. What is the ratio of the Exports(as % of merchandise exports) in 1965 in Netherlands to that in Panama?
Give a very brief answer. 28.9. What is the difference between the highest and the second highest Exports(as % of merchandise exports) of 1962?
Provide a succinct answer. 6.42. What is the difference between the highest and the second highest Exports(as % of merchandise exports) of 1963?
Offer a very short reply. 14.04. What is the difference between the highest and the second highest Exports(as % of merchandise exports) of 1964?
Give a very brief answer. 12.97. What is the difference between the highest and the second highest Exports(as % of merchandise exports) of 1965?
Your answer should be compact. 14.01. What is the difference between the highest and the lowest Exports(as % of merchandise exports) in 1962?
Keep it short and to the point. 91.97. What is the difference between the highest and the lowest Exports(as % of merchandise exports) in 1963?
Your answer should be very brief. 87.97. What is the difference between the highest and the lowest Exports(as % of merchandise exports) of 1964?
Provide a short and direct response. 88.15. What is the difference between the highest and the lowest Exports(as % of merchandise exports) of 1965?
Make the answer very short. 88.65. 